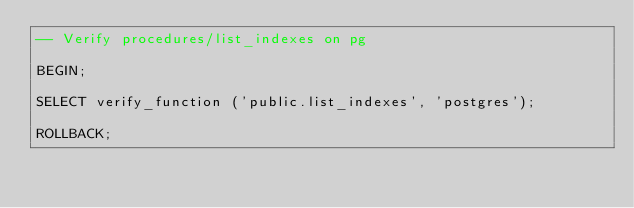<code> <loc_0><loc_0><loc_500><loc_500><_SQL_>-- Verify procedures/list_indexes on pg

BEGIN;

SELECT verify_function ('public.list_indexes', 'postgres');

ROLLBACK;
</code> 